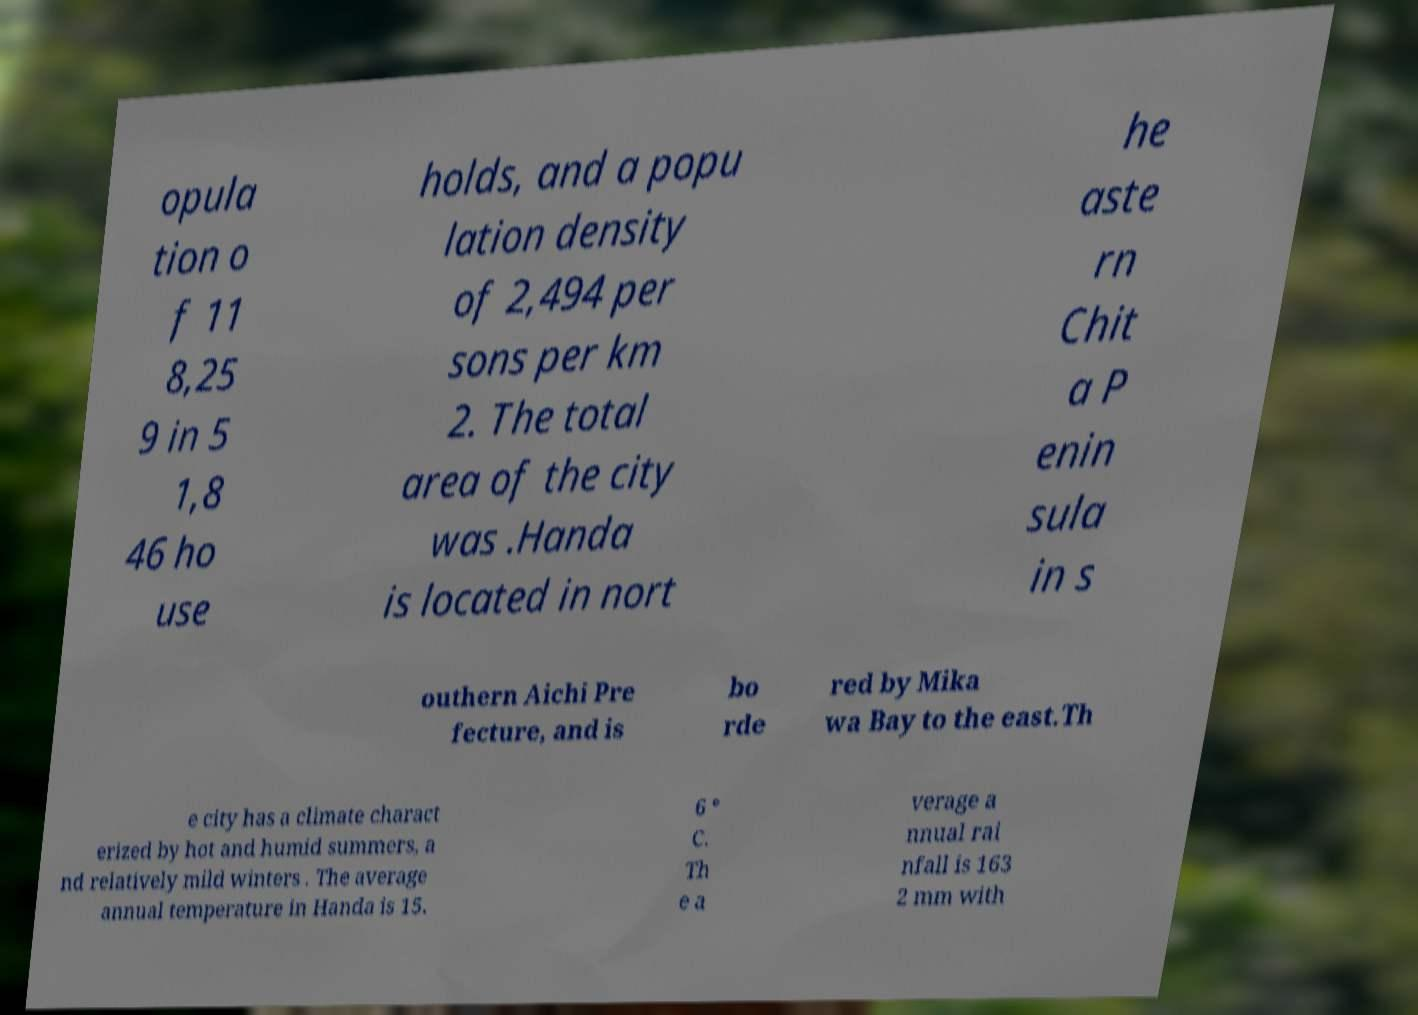Could you extract and type out the text from this image? opula tion o f 11 8,25 9 in 5 1,8 46 ho use holds, and a popu lation density of 2,494 per sons per km 2. The total area of the city was .Handa is located in nort he aste rn Chit a P enin sula in s outhern Aichi Pre fecture, and is bo rde red by Mika wa Bay to the east.Th e city has a climate charact erized by hot and humid summers, a nd relatively mild winters . The average annual temperature in Handa is 15. 6 ° C. Th e a verage a nnual rai nfall is 163 2 mm with 